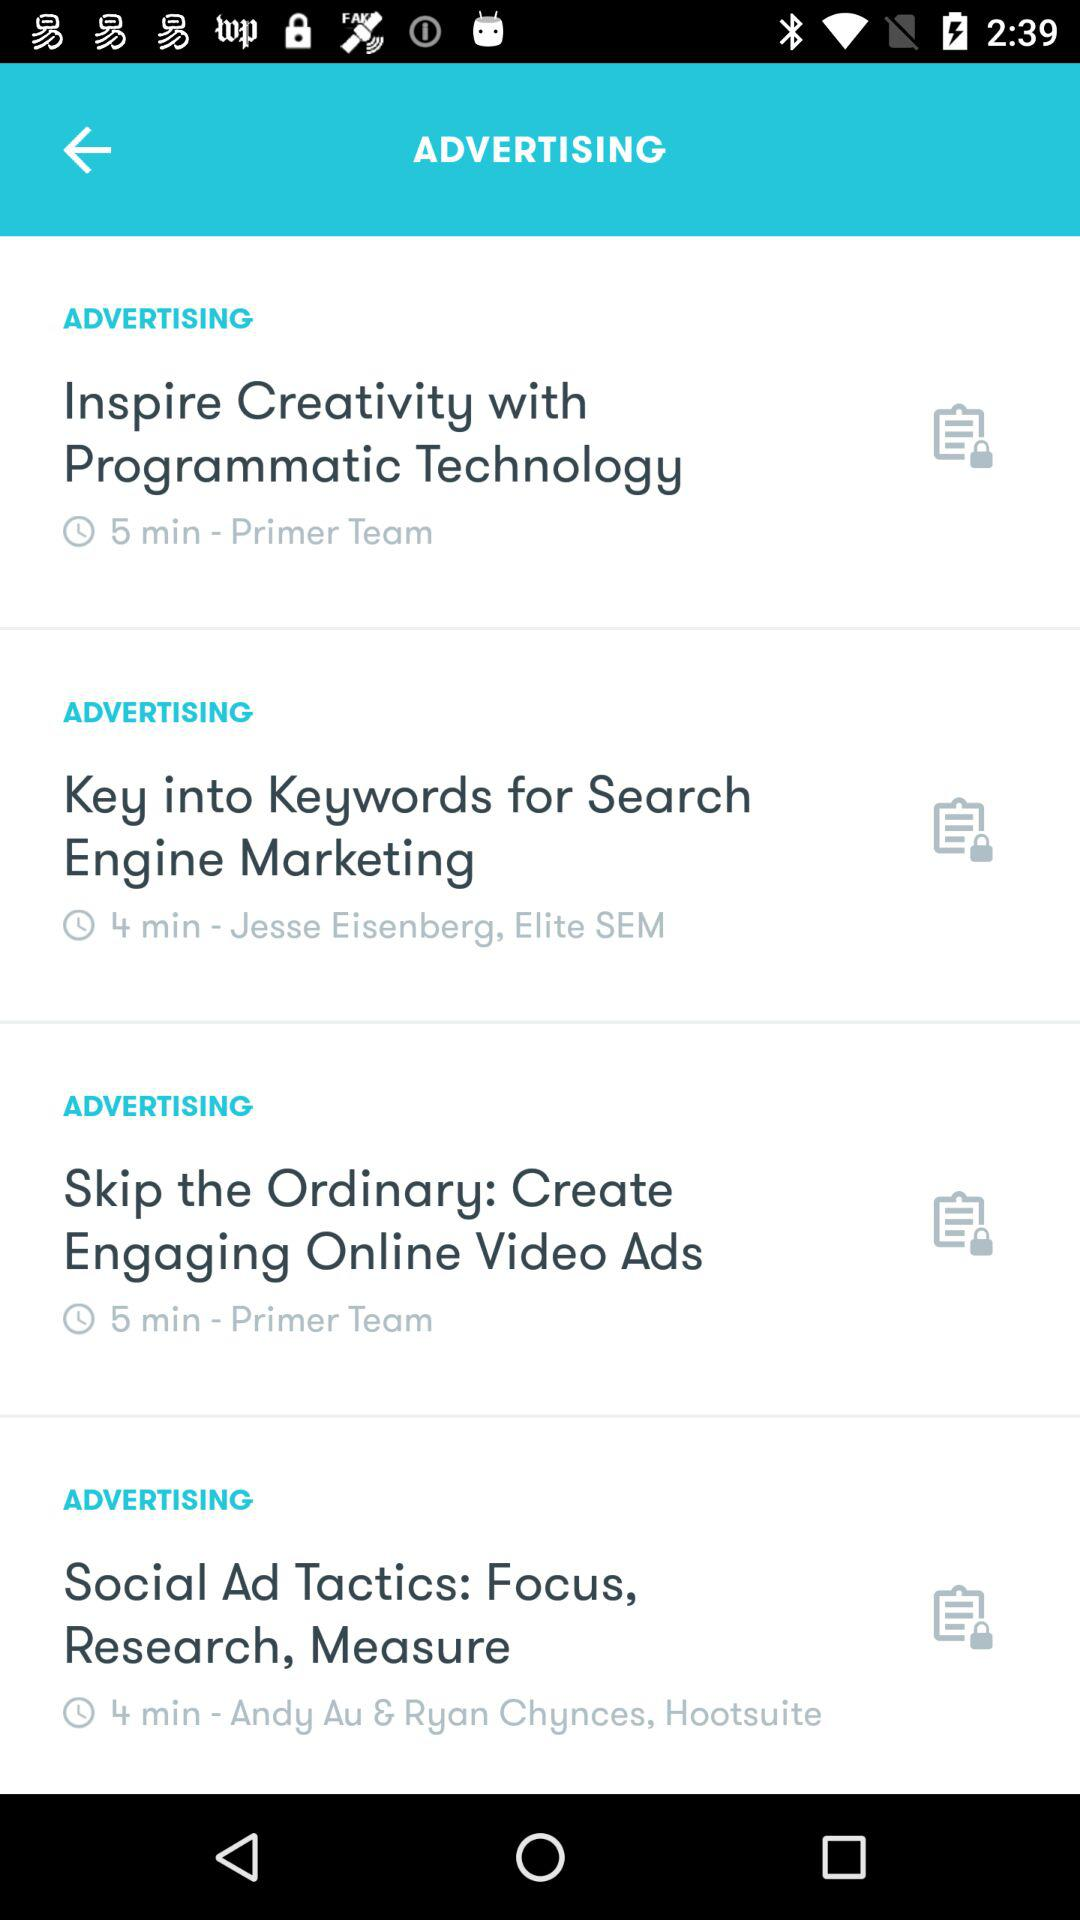Who is the advertiser of Inspire Creativity with Programmatic Technology? The advertiser of Inspire Creativity with Programmatic Technology is Primer Team. 